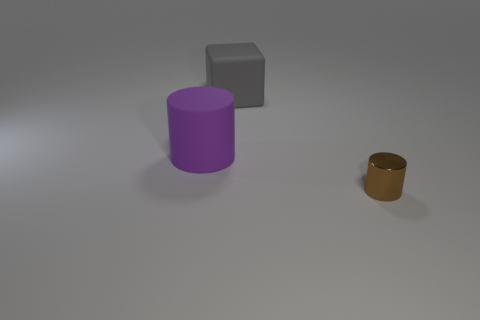Add 1 purple cylinders. How many objects exist? 4 Subtract all cubes. How many objects are left? 2 Add 2 big cubes. How many big cubes exist? 3 Subtract 0 red balls. How many objects are left? 3 Subtract all large rubber cylinders. Subtract all metallic cylinders. How many objects are left? 1 Add 1 brown things. How many brown things are left? 2 